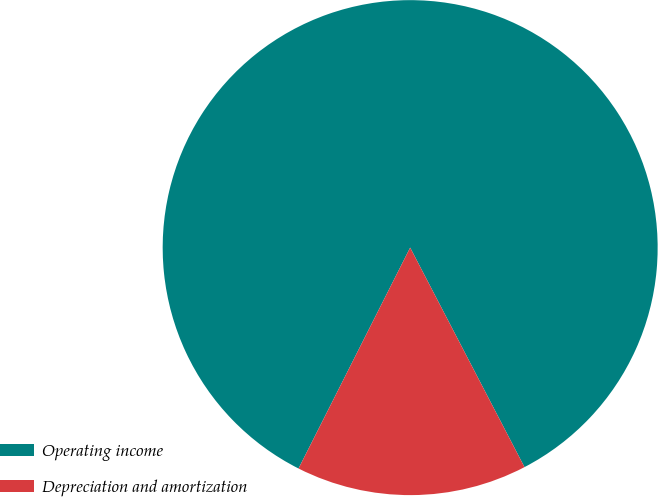Convert chart. <chart><loc_0><loc_0><loc_500><loc_500><pie_chart><fcel>Operating income<fcel>Depreciation and amortization<nl><fcel>84.91%<fcel>15.09%<nl></chart> 